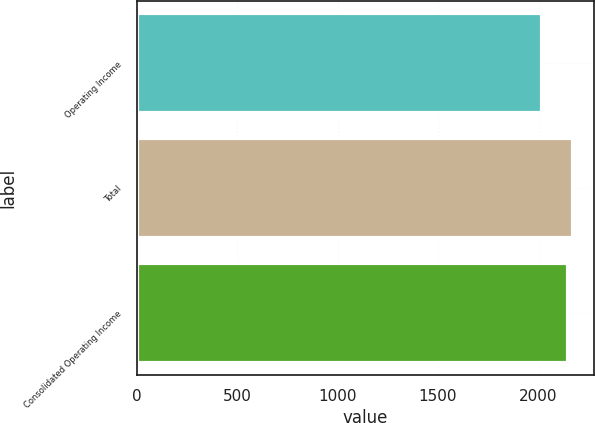<chart> <loc_0><loc_0><loc_500><loc_500><bar_chart><fcel>Operating Income<fcel>Total<fcel>Consolidated Operating Income<nl><fcel>2019<fcel>2169.8<fcel>2144.4<nl></chart> 